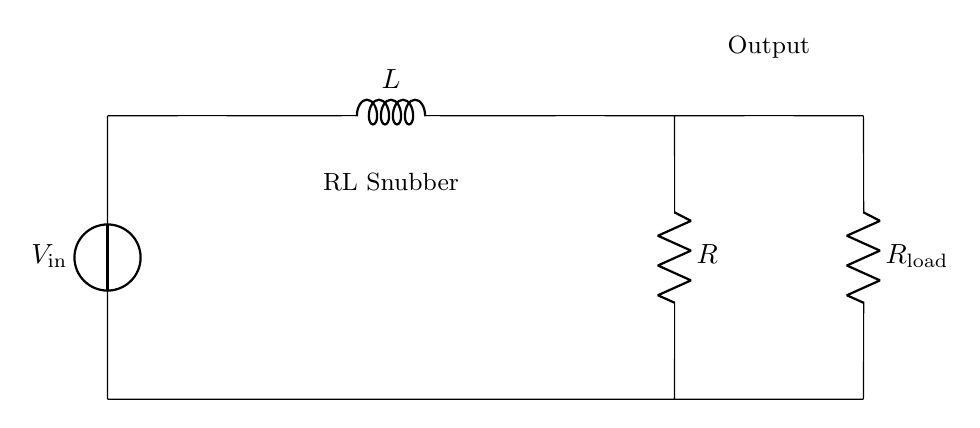What is the input voltage in this circuit? The input voltage is labeled as V_in, situated at the top left corner of the circuit diagram, indicating the voltage supply entering the circuit.
Answer: V_in What is the component labeled L? The component labeled L in the circuit is an inductor, which is used to store energy in a magnetic field when electric current passes through it.
Answer: Inductor What are the resistances in this circuit? There are two resistors labeled R and R_load, which are positioned in the circuit; R is part of the operating circuit, and R_load serves as the load connected to the output.
Answer: R and R_load How many components are in series in this circuit? The components in series include the voltage source, inductor, and the first resistor, all connected sequentially; thus, there are three components in series.
Answer: Three What is the purpose of the RL snubber? The RL snubber's purpose is to reduce voltage spikes in power supplies, primarily when interacting with inductive loads that can generate back electromotive force (EMF).
Answer: Reduce voltage spikes Why might this circuit be beneficial for load protection? This circuit helps protect the load by suppressing voltage spikes, which can damage other components downstream; it does this through the cooperative action of the resistor and inductor.
Answer: Load protection How does the inductor's placement affect your circuit? The inductor's placement before the resistor means it can capture and dampen the voltage spikes before they reach the load, making the circuit more stable.
Answer: Stabilizes circuit 